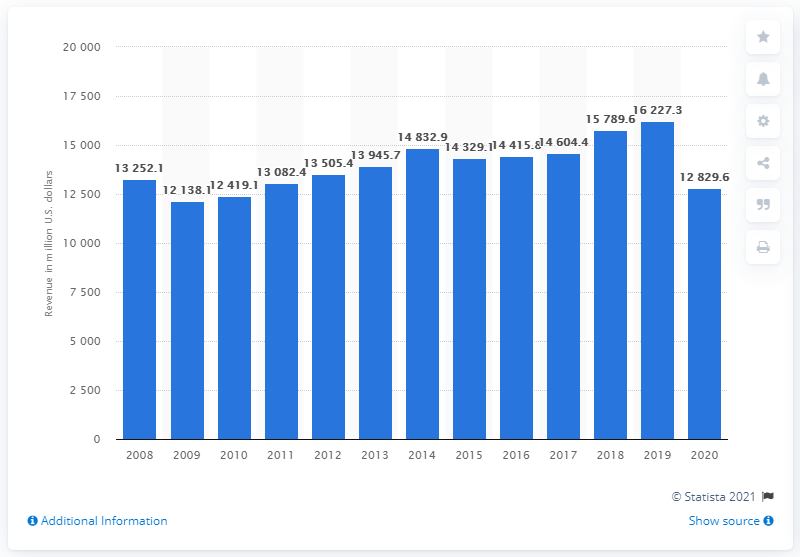Identify some key points in this picture. In 2020, Aramark's global revenue was approximately $128,296.6 million. 